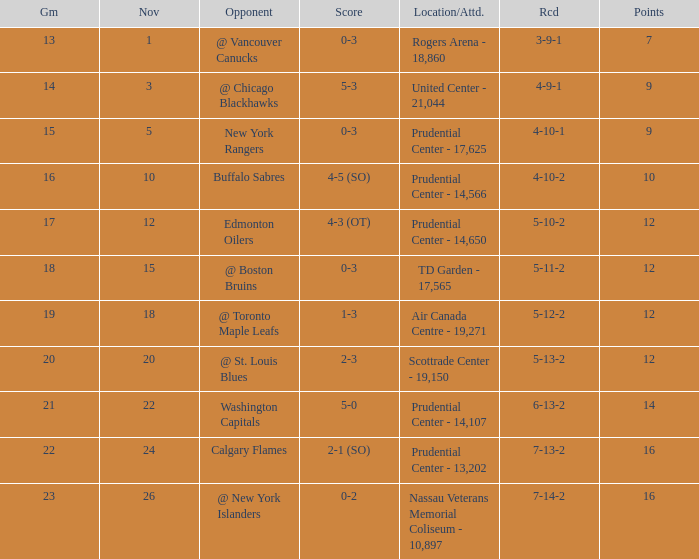What is the total number of locations that had a score of 1-3? 1.0. 